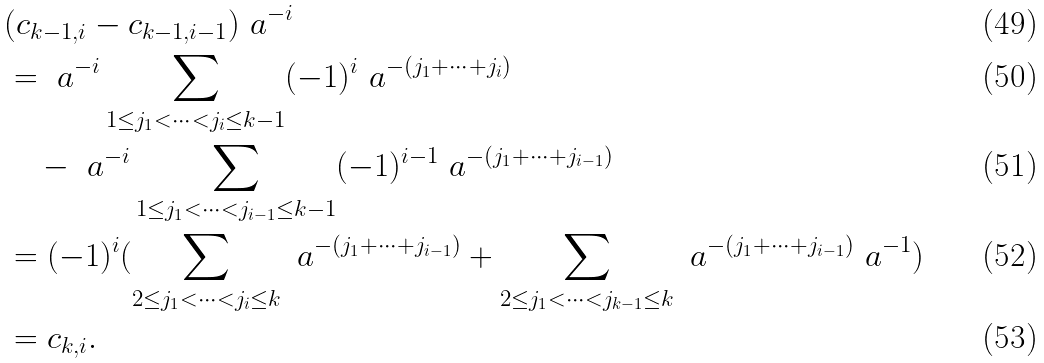<formula> <loc_0><loc_0><loc_500><loc_500>& ( c _ { k - 1 , i } - c _ { k - 1 , i - 1 } ) \ a ^ { - i } \\ & = \ a ^ { - i } \sum _ { 1 \leq j _ { 1 } < \cdots < j _ { i } \leq k - 1 } ( - 1 ) ^ { i } \ a ^ { - ( j _ { 1 } + \cdots + j _ { i } ) } \\ & \quad - \ a ^ { - i } \sum _ { 1 \leq j _ { 1 } < \cdots < j _ { i - 1 } \leq k - 1 } ( - 1 ) ^ { i - 1 } \ a ^ { - ( j _ { 1 } + \cdots + j _ { i - 1 } ) } \\ & = ( - 1 ) ^ { i } ( \sum _ { 2 \leq j _ { 1 } < \cdots < j _ { i } \leq k } \ a ^ { - ( j _ { 1 } + \cdots + j _ { i - 1 } ) } + \sum _ { 2 \leq j _ { 1 } < \cdots < j _ { k - 1 } \leq k } \ a ^ { - ( j _ { 1 } + \cdots + j _ { i - 1 } ) } \ a ^ { - 1 } ) \\ & = c _ { k , i } .</formula> 